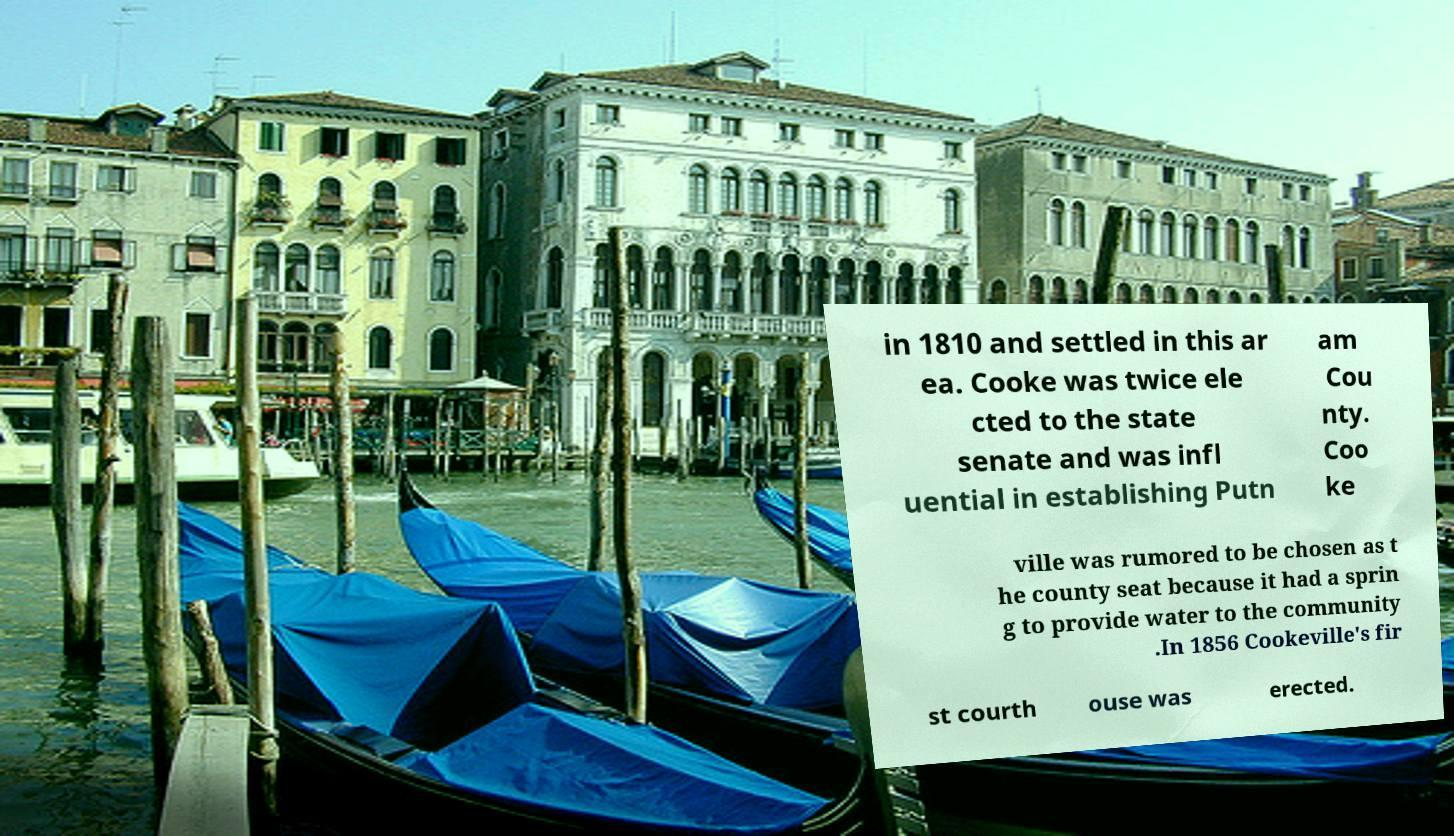Please read and relay the text visible in this image. What does it say? in 1810 and settled in this ar ea. Cooke was twice ele cted to the state senate and was infl uential in establishing Putn am Cou nty. Coo ke ville was rumored to be chosen as t he county seat because it had a sprin g to provide water to the community .In 1856 Cookeville's fir st courth ouse was erected. 